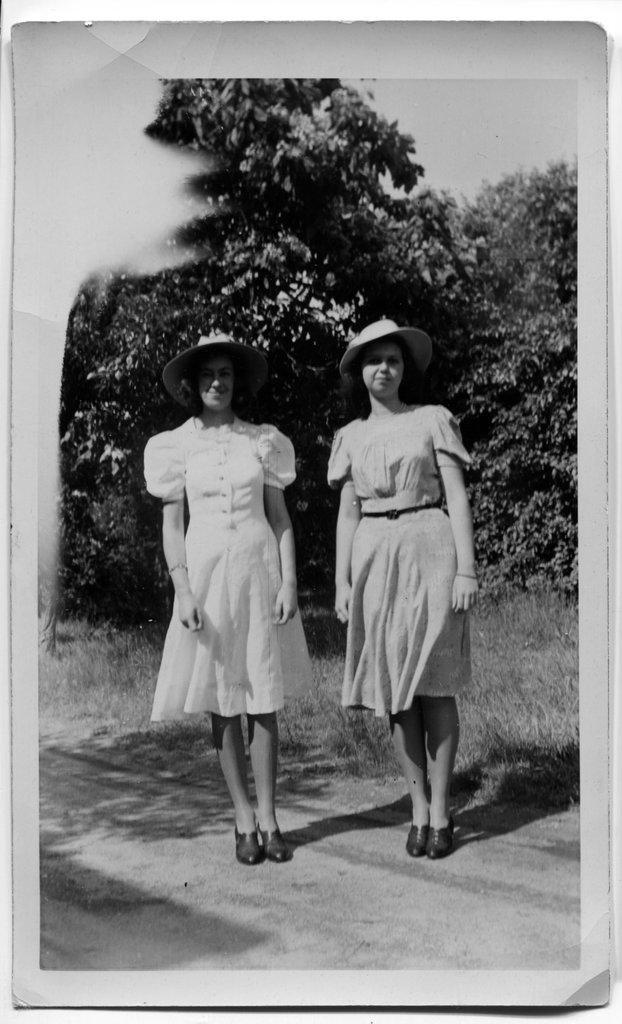Please provide a concise description of this image. In this picture we can see two women, they wore caps, behind to them we can see few trees and grass, and it is a black and white photography. 